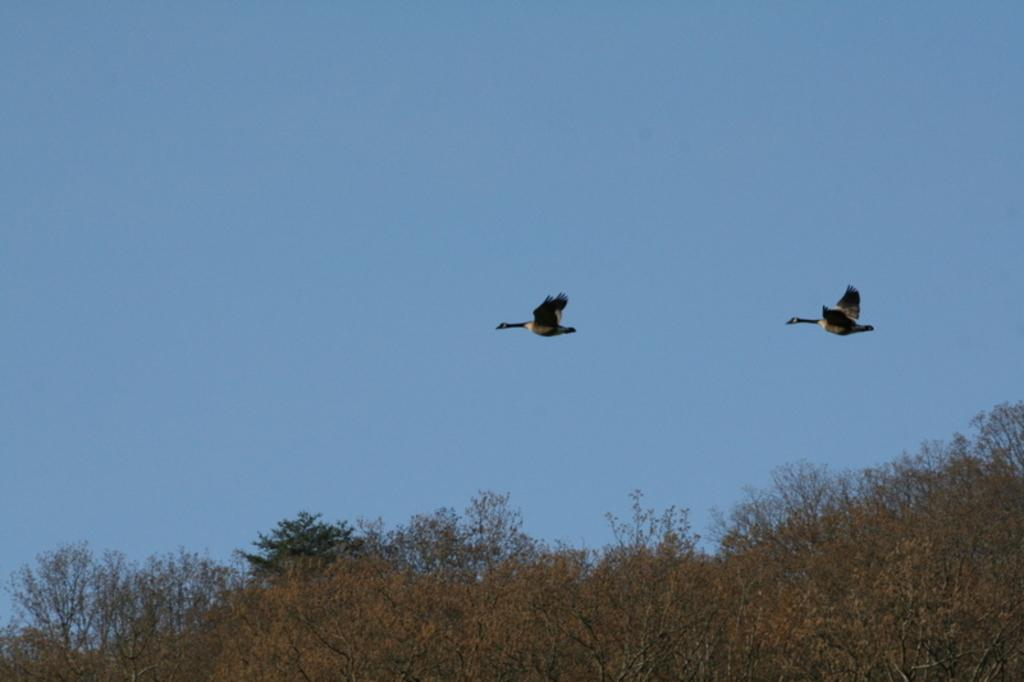What is happening in the image involving birds? There are two birds flying in the image. What type of vegetation is present at the bottom of the image? There are trees at the bottom of the image. What can be seen in the background of the image? The sky is visible in the background of the image. What type of rod can be seen in the image? There is no rod present in the image. What stage of development is the bird in the image? The image does not provide enough information to determine the stage of development of the birds. 